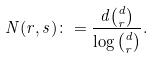<formula> <loc_0><loc_0><loc_500><loc_500>N ( r , s ) \colon = \frac { d { d \choose r } } { \log { d \choose r } } .</formula> 